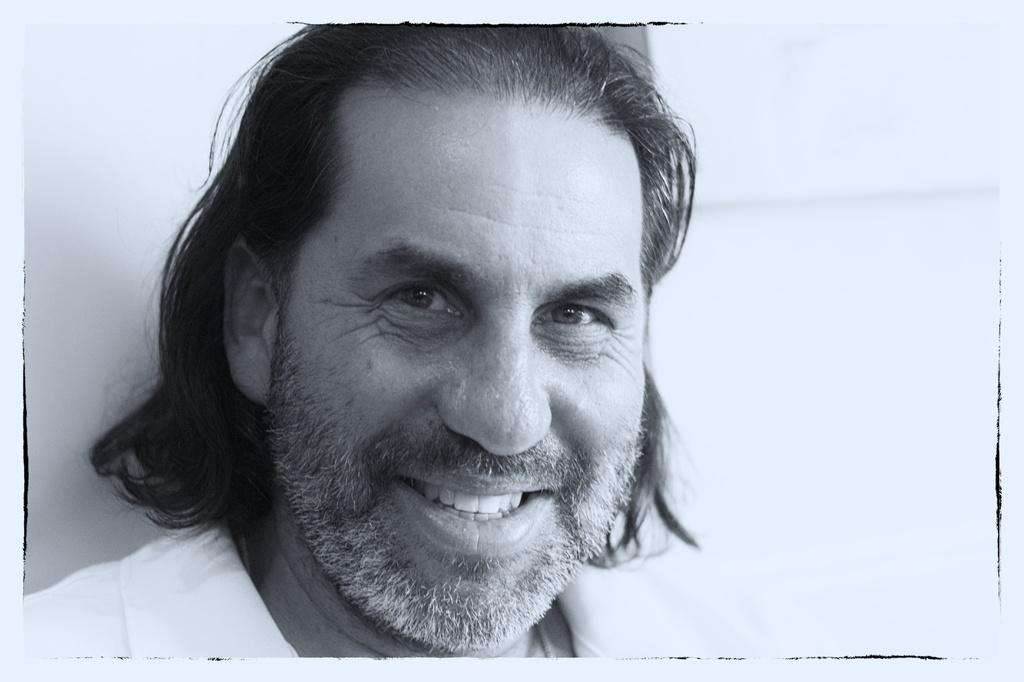Who is present in the image? There is a man in the image. What is the man wearing? The man is wearing a white shirt. What is the man's facial expression? The man has a smiling face. What color is the background of the image? The background of the image is white. What type of bottle is the servant holding in the image? There is no servant or bottle present in the image. 